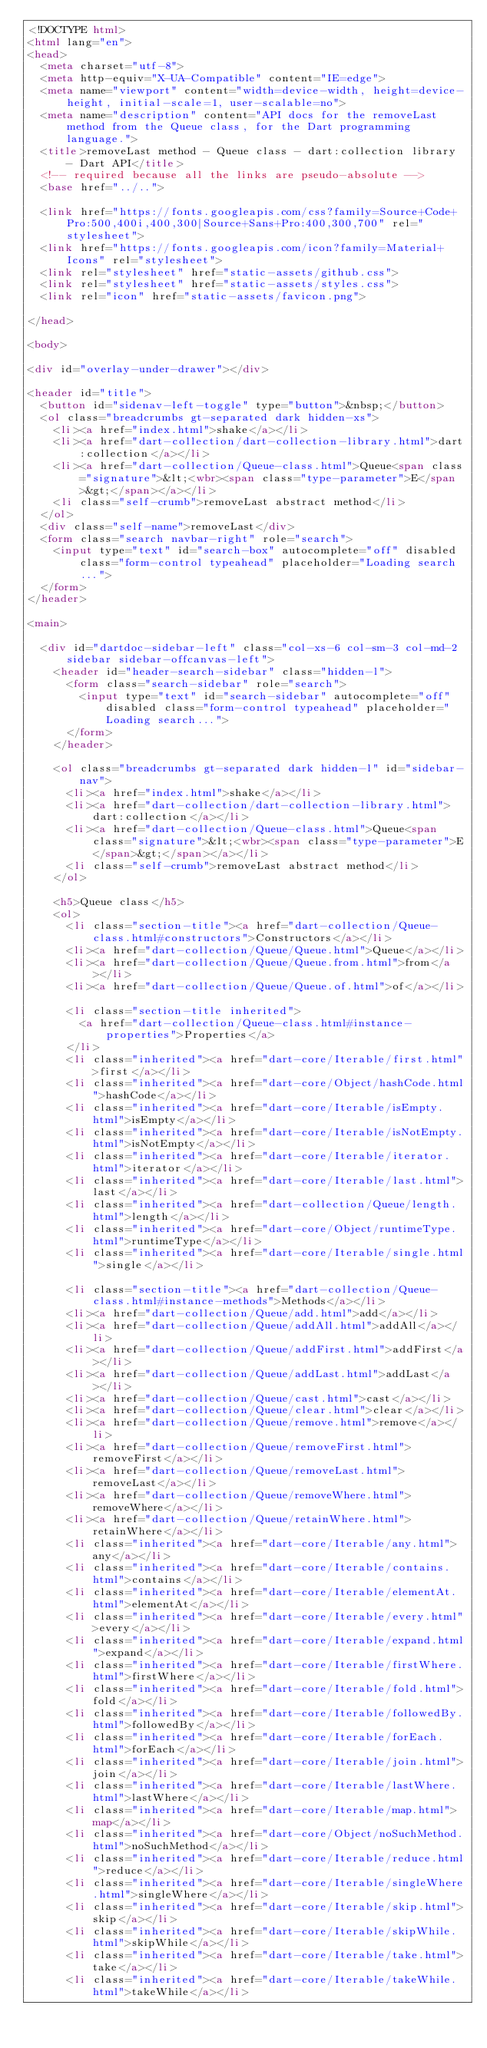<code> <loc_0><loc_0><loc_500><loc_500><_HTML_><!DOCTYPE html>
<html lang="en">
<head>
  <meta charset="utf-8">
  <meta http-equiv="X-UA-Compatible" content="IE=edge">
  <meta name="viewport" content="width=device-width, height=device-height, initial-scale=1, user-scalable=no">
  <meta name="description" content="API docs for the removeLast method from the Queue class, for the Dart programming language.">
  <title>removeLast method - Queue class - dart:collection library - Dart API</title>
  <!-- required because all the links are pseudo-absolute -->
  <base href="../..">

  <link href="https://fonts.googleapis.com/css?family=Source+Code+Pro:500,400i,400,300|Source+Sans+Pro:400,300,700" rel="stylesheet">
  <link href="https://fonts.googleapis.com/icon?family=Material+Icons" rel="stylesheet">
  <link rel="stylesheet" href="static-assets/github.css">
  <link rel="stylesheet" href="static-assets/styles.css">
  <link rel="icon" href="static-assets/favicon.png">
  
</head>

<body>

<div id="overlay-under-drawer"></div>

<header id="title">
  <button id="sidenav-left-toggle" type="button">&nbsp;</button>
  <ol class="breadcrumbs gt-separated dark hidden-xs">
    <li><a href="index.html">shake</a></li>
    <li><a href="dart-collection/dart-collection-library.html">dart:collection</a></li>
    <li><a href="dart-collection/Queue-class.html">Queue<span class="signature">&lt;<wbr><span class="type-parameter">E</span>&gt;</span></a></li>
    <li class="self-crumb">removeLast abstract method</li>
  </ol>
  <div class="self-name">removeLast</div>
  <form class="search navbar-right" role="search">
    <input type="text" id="search-box" autocomplete="off" disabled class="form-control typeahead" placeholder="Loading search...">
  </form>
</header>

<main>

  <div id="dartdoc-sidebar-left" class="col-xs-6 col-sm-3 col-md-2 sidebar sidebar-offcanvas-left">
    <header id="header-search-sidebar" class="hidden-l">
      <form class="search-sidebar" role="search">
        <input type="text" id="search-sidebar" autocomplete="off" disabled class="form-control typeahead" placeholder="Loading search...">
      </form>
    </header>
    
    <ol class="breadcrumbs gt-separated dark hidden-l" id="sidebar-nav">
      <li><a href="index.html">shake</a></li>
      <li><a href="dart-collection/dart-collection-library.html">dart:collection</a></li>
      <li><a href="dart-collection/Queue-class.html">Queue<span class="signature">&lt;<wbr><span class="type-parameter">E</span>&gt;</span></a></li>
      <li class="self-crumb">removeLast abstract method</li>
    </ol>
    
    <h5>Queue class</h5>
    <ol>
      <li class="section-title"><a href="dart-collection/Queue-class.html#constructors">Constructors</a></li>
      <li><a href="dart-collection/Queue/Queue.html">Queue</a></li>
      <li><a href="dart-collection/Queue/Queue.from.html">from</a></li>
      <li><a href="dart-collection/Queue/Queue.of.html">of</a></li>
    
      <li class="section-title inherited">
        <a href="dart-collection/Queue-class.html#instance-properties">Properties</a>
      </li>
      <li class="inherited"><a href="dart-core/Iterable/first.html">first</a></li>
      <li class="inherited"><a href="dart-core/Object/hashCode.html">hashCode</a></li>
      <li class="inherited"><a href="dart-core/Iterable/isEmpty.html">isEmpty</a></li>
      <li class="inherited"><a href="dart-core/Iterable/isNotEmpty.html">isNotEmpty</a></li>
      <li class="inherited"><a href="dart-core/Iterable/iterator.html">iterator</a></li>
      <li class="inherited"><a href="dart-core/Iterable/last.html">last</a></li>
      <li class="inherited"><a href="dart-collection/Queue/length.html">length</a></li>
      <li class="inherited"><a href="dart-core/Object/runtimeType.html">runtimeType</a></li>
      <li class="inherited"><a href="dart-core/Iterable/single.html">single</a></li>
    
      <li class="section-title"><a href="dart-collection/Queue-class.html#instance-methods">Methods</a></li>
      <li><a href="dart-collection/Queue/add.html">add</a></li>
      <li><a href="dart-collection/Queue/addAll.html">addAll</a></li>
      <li><a href="dart-collection/Queue/addFirst.html">addFirst</a></li>
      <li><a href="dart-collection/Queue/addLast.html">addLast</a></li>
      <li><a href="dart-collection/Queue/cast.html">cast</a></li>
      <li><a href="dart-collection/Queue/clear.html">clear</a></li>
      <li><a href="dart-collection/Queue/remove.html">remove</a></li>
      <li><a href="dart-collection/Queue/removeFirst.html">removeFirst</a></li>
      <li><a href="dart-collection/Queue/removeLast.html">removeLast</a></li>
      <li><a href="dart-collection/Queue/removeWhere.html">removeWhere</a></li>
      <li><a href="dart-collection/Queue/retainWhere.html">retainWhere</a></li>
      <li class="inherited"><a href="dart-core/Iterable/any.html">any</a></li>
      <li class="inherited"><a href="dart-core/Iterable/contains.html">contains</a></li>
      <li class="inherited"><a href="dart-core/Iterable/elementAt.html">elementAt</a></li>
      <li class="inherited"><a href="dart-core/Iterable/every.html">every</a></li>
      <li class="inherited"><a href="dart-core/Iterable/expand.html">expand</a></li>
      <li class="inherited"><a href="dart-core/Iterable/firstWhere.html">firstWhere</a></li>
      <li class="inherited"><a href="dart-core/Iterable/fold.html">fold</a></li>
      <li class="inherited"><a href="dart-core/Iterable/followedBy.html">followedBy</a></li>
      <li class="inherited"><a href="dart-core/Iterable/forEach.html">forEach</a></li>
      <li class="inherited"><a href="dart-core/Iterable/join.html">join</a></li>
      <li class="inherited"><a href="dart-core/Iterable/lastWhere.html">lastWhere</a></li>
      <li class="inherited"><a href="dart-core/Iterable/map.html">map</a></li>
      <li class="inherited"><a href="dart-core/Object/noSuchMethod.html">noSuchMethod</a></li>
      <li class="inherited"><a href="dart-core/Iterable/reduce.html">reduce</a></li>
      <li class="inherited"><a href="dart-core/Iterable/singleWhere.html">singleWhere</a></li>
      <li class="inherited"><a href="dart-core/Iterable/skip.html">skip</a></li>
      <li class="inherited"><a href="dart-core/Iterable/skipWhile.html">skipWhile</a></li>
      <li class="inherited"><a href="dart-core/Iterable/take.html">take</a></li>
      <li class="inherited"><a href="dart-core/Iterable/takeWhile.html">takeWhile</a></li></code> 